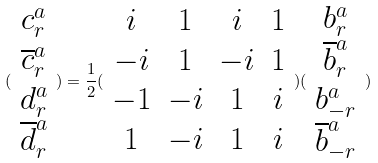Convert formula to latex. <formula><loc_0><loc_0><loc_500><loc_500>( \begin{array} { c } c _ { r } ^ { a } \\ \overline { c } _ { r } ^ { a } \\ d _ { r } ^ { a } \\ \overline { d } _ { r } ^ { a } \end{array} ) = \frac { 1 } { 2 } ( \begin{array} { c c c c } i & 1 & i & 1 \\ - i & 1 & - i & 1 \\ - 1 & - i & 1 & i \\ 1 & - i & 1 & i \end{array} ) ( \begin{array} { c } b _ { r } ^ { a } \\ \overline { b } _ { r } ^ { a } \\ b _ { - r } ^ { a } \\ \overline { b } _ { - r } ^ { a } \end{array} )</formula> 